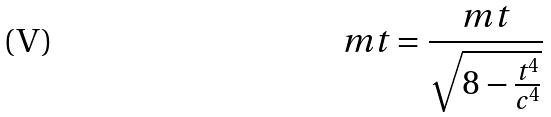<formula> <loc_0><loc_0><loc_500><loc_500>m t = \frac { m t } { \sqrt { 8 - \frac { t ^ { 4 } } { c ^ { 4 } } } }</formula> 